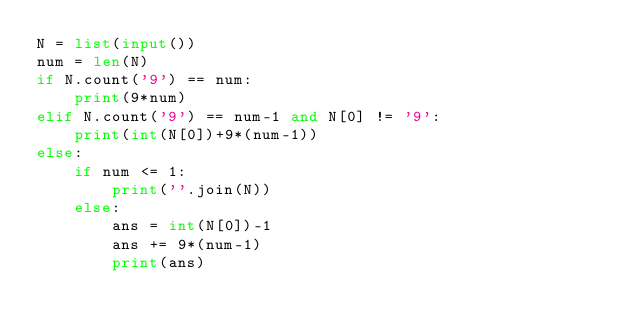<code> <loc_0><loc_0><loc_500><loc_500><_Python_>N = list(input())
num = len(N)
if N.count('9') == num:
    print(9*num)
elif N.count('9') == num-1 and N[0] != '9':
    print(int(N[0])+9*(num-1))
else:
    if num <= 1:
        print(''.join(N))
    else:
        ans = int(N[0])-1
        ans += 9*(num-1)
        print(ans)
</code> 